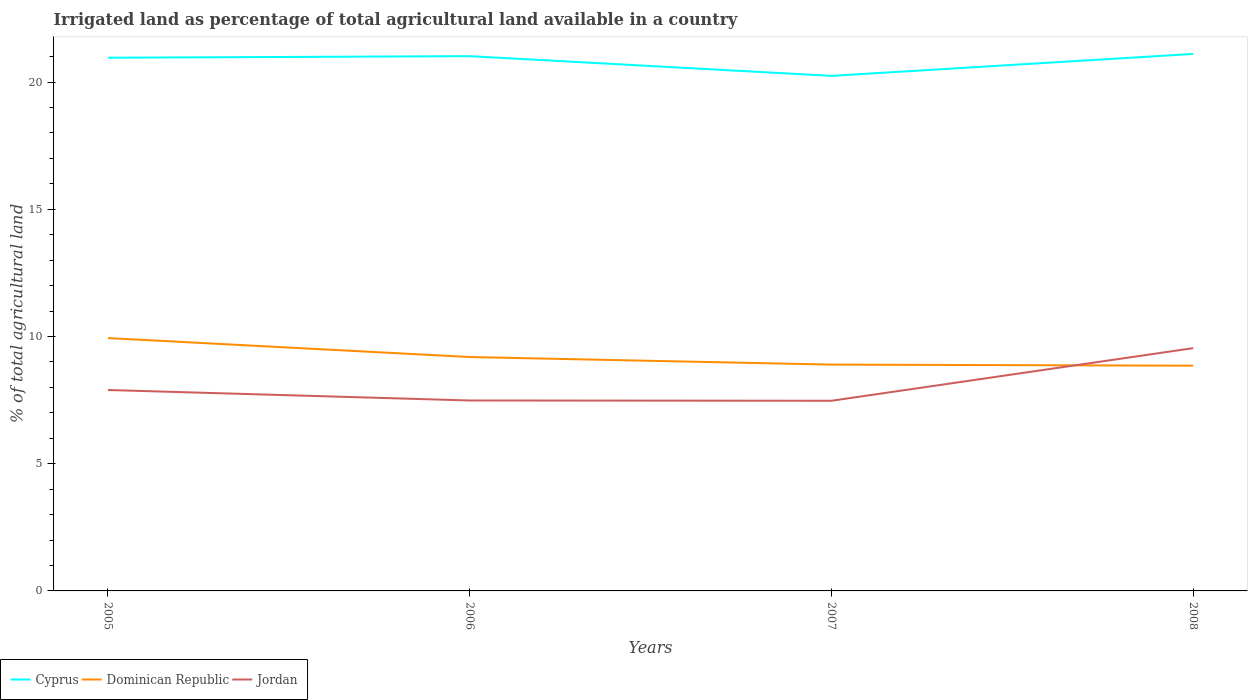Does the line corresponding to Cyprus intersect with the line corresponding to Jordan?
Give a very brief answer. No. Across all years, what is the maximum percentage of irrigated land in Cyprus?
Ensure brevity in your answer.  20.24. What is the total percentage of irrigated land in Jordan in the graph?
Offer a very short reply. 0.01. What is the difference between the highest and the second highest percentage of irrigated land in Jordan?
Offer a terse response. 2.07. What is the difference between the highest and the lowest percentage of irrigated land in Cyprus?
Give a very brief answer. 3. How many lines are there?
Keep it short and to the point. 3. How many years are there in the graph?
Your answer should be compact. 4. Does the graph contain any zero values?
Make the answer very short. No. How many legend labels are there?
Your response must be concise. 3. What is the title of the graph?
Make the answer very short. Irrigated land as percentage of total agricultural land available in a country. Does "Ghana" appear as one of the legend labels in the graph?
Provide a short and direct response. No. What is the label or title of the Y-axis?
Your answer should be compact. % of total agricultural land. What is the % of total agricultural land of Cyprus in 2005?
Provide a short and direct response. 20.96. What is the % of total agricultural land in Dominican Republic in 2005?
Your answer should be very brief. 9.94. What is the % of total agricultural land of Jordan in 2005?
Offer a very short reply. 7.9. What is the % of total agricultural land in Cyprus in 2006?
Provide a short and direct response. 21.02. What is the % of total agricultural land in Dominican Republic in 2006?
Provide a short and direct response. 9.19. What is the % of total agricultural land in Jordan in 2006?
Your response must be concise. 7.49. What is the % of total agricultural land in Cyprus in 2007?
Ensure brevity in your answer.  20.24. What is the % of total agricultural land in Dominican Republic in 2007?
Offer a terse response. 8.9. What is the % of total agricultural land in Jordan in 2007?
Keep it short and to the point. 7.47. What is the % of total agricultural land of Cyprus in 2008?
Offer a terse response. 21.11. What is the % of total agricultural land of Dominican Republic in 2008?
Give a very brief answer. 8.85. What is the % of total agricultural land of Jordan in 2008?
Give a very brief answer. 9.54. Across all years, what is the maximum % of total agricultural land of Cyprus?
Offer a very short reply. 21.11. Across all years, what is the maximum % of total agricultural land of Dominican Republic?
Keep it short and to the point. 9.94. Across all years, what is the maximum % of total agricultural land in Jordan?
Your answer should be compact. 9.54. Across all years, what is the minimum % of total agricultural land of Cyprus?
Make the answer very short. 20.24. Across all years, what is the minimum % of total agricultural land in Dominican Republic?
Provide a short and direct response. 8.85. Across all years, what is the minimum % of total agricultural land in Jordan?
Your answer should be very brief. 7.47. What is the total % of total agricultural land in Cyprus in the graph?
Offer a very short reply. 83.33. What is the total % of total agricultural land in Dominican Republic in the graph?
Make the answer very short. 36.88. What is the total % of total agricultural land of Jordan in the graph?
Offer a terse response. 32.4. What is the difference between the % of total agricultural land in Cyprus in 2005 and that in 2006?
Provide a succinct answer. -0.06. What is the difference between the % of total agricultural land in Dominican Republic in 2005 and that in 2006?
Offer a terse response. 0.74. What is the difference between the % of total agricultural land of Jordan in 2005 and that in 2006?
Provide a short and direct response. 0.41. What is the difference between the % of total agricultural land of Cyprus in 2005 and that in 2007?
Your answer should be very brief. 0.71. What is the difference between the % of total agricultural land in Dominican Republic in 2005 and that in 2007?
Provide a succinct answer. 1.04. What is the difference between the % of total agricultural land in Jordan in 2005 and that in 2007?
Your answer should be compact. 0.42. What is the difference between the % of total agricultural land in Cyprus in 2005 and that in 2008?
Your answer should be compact. -0.15. What is the difference between the % of total agricultural land of Dominican Republic in 2005 and that in 2008?
Offer a terse response. 1.09. What is the difference between the % of total agricultural land in Jordan in 2005 and that in 2008?
Offer a very short reply. -1.65. What is the difference between the % of total agricultural land in Cyprus in 2006 and that in 2007?
Your response must be concise. 0.77. What is the difference between the % of total agricultural land in Dominican Republic in 2006 and that in 2007?
Your answer should be very brief. 0.3. What is the difference between the % of total agricultural land of Jordan in 2006 and that in 2007?
Provide a succinct answer. 0.01. What is the difference between the % of total agricultural land in Cyprus in 2006 and that in 2008?
Ensure brevity in your answer.  -0.09. What is the difference between the % of total agricultural land of Dominican Republic in 2006 and that in 2008?
Provide a succinct answer. 0.34. What is the difference between the % of total agricultural land of Jordan in 2006 and that in 2008?
Your answer should be compact. -2.06. What is the difference between the % of total agricultural land of Cyprus in 2007 and that in 2008?
Your answer should be compact. -0.86. What is the difference between the % of total agricultural land in Dominican Republic in 2007 and that in 2008?
Keep it short and to the point. 0.04. What is the difference between the % of total agricultural land of Jordan in 2007 and that in 2008?
Ensure brevity in your answer.  -2.07. What is the difference between the % of total agricultural land of Cyprus in 2005 and the % of total agricultural land of Dominican Republic in 2006?
Provide a short and direct response. 11.76. What is the difference between the % of total agricultural land of Cyprus in 2005 and the % of total agricultural land of Jordan in 2006?
Provide a succinct answer. 13.47. What is the difference between the % of total agricultural land in Dominican Republic in 2005 and the % of total agricultural land in Jordan in 2006?
Your answer should be compact. 2.45. What is the difference between the % of total agricultural land in Cyprus in 2005 and the % of total agricultural land in Dominican Republic in 2007?
Keep it short and to the point. 12.06. What is the difference between the % of total agricultural land in Cyprus in 2005 and the % of total agricultural land in Jordan in 2007?
Give a very brief answer. 13.48. What is the difference between the % of total agricultural land of Dominican Republic in 2005 and the % of total agricultural land of Jordan in 2007?
Ensure brevity in your answer.  2.46. What is the difference between the % of total agricultural land of Cyprus in 2005 and the % of total agricultural land of Dominican Republic in 2008?
Offer a terse response. 12.11. What is the difference between the % of total agricultural land in Cyprus in 2005 and the % of total agricultural land in Jordan in 2008?
Offer a very short reply. 11.42. What is the difference between the % of total agricultural land in Dominican Republic in 2005 and the % of total agricultural land in Jordan in 2008?
Your answer should be very brief. 0.4. What is the difference between the % of total agricultural land of Cyprus in 2006 and the % of total agricultural land of Dominican Republic in 2007?
Your response must be concise. 12.12. What is the difference between the % of total agricultural land in Cyprus in 2006 and the % of total agricultural land in Jordan in 2007?
Provide a short and direct response. 13.54. What is the difference between the % of total agricultural land in Dominican Republic in 2006 and the % of total agricultural land in Jordan in 2007?
Ensure brevity in your answer.  1.72. What is the difference between the % of total agricultural land in Cyprus in 2006 and the % of total agricultural land in Dominican Republic in 2008?
Your answer should be compact. 12.17. What is the difference between the % of total agricultural land of Cyprus in 2006 and the % of total agricultural land of Jordan in 2008?
Your answer should be very brief. 11.48. What is the difference between the % of total agricultural land of Dominican Republic in 2006 and the % of total agricultural land of Jordan in 2008?
Your response must be concise. -0.35. What is the difference between the % of total agricultural land of Cyprus in 2007 and the % of total agricultural land of Dominican Republic in 2008?
Give a very brief answer. 11.39. What is the difference between the % of total agricultural land in Cyprus in 2007 and the % of total agricultural land in Jordan in 2008?
Your response must be concise. 10.7. What is the difference between the % of total agricultural land in Dominican Republic in 2007 and the % of total agricultural land in Jordan in 2008?
Your answer should be compact. -0.65. What is the average % of total agricultural land in Cyprus per year?
Ensure brevity in your answer.  20.83. What is the average % of total agricultural land in Dominican Republic per year?
Make the answer very short. 9.22. What is the average % of total agricultural land of Jordan per year?
Your answer should be very brief. 8.1. In the year 2005, what is the difference between the % of total agricultural land of Cyprus and % of total agricultural land of Dominican Republic?
Offer a very short reply. 11.02. In the year 2005, what is the difference between the % of total agricultural land in Cyprus and % of total agricultural land in Jordan?
Your answer should be very brief. 13.06. In the year 2005, what is the difference between the % of total agricultural land of Dominican Republic and % of total agricultural land of Jordan?
Give a very brief answer. 2.04. In the year 2006, what is the difference between the % of total agricultural land in Cyprus and % of total agricultural land in Dominican Republic?
Keep it short and to the point. 11.83. In the year 2006, what is the difference between the % of total agricultural land of Cyprus and % of total agricultural land of Jordan?
Your answer should be very brief. 13.53. In the year 2006, what is the difference between the % of total agricultural land of Dominican Republic and % of total agricultural land of Jordan?
Give a very brief answer. 1.71. In the year 2007, what is the difference between the % of total agricultural land of Cyprus and % of total agricultural land of Dominican Republic?
Ensure brevity in your answer.  11.35. In the year 2007, what is the difference between the % of total agricultural land in Cyprus and % of total agricultural land in Jordan?
Give a very brief answer. 12.77. In the year 2007, what is the difference between the % of total agricultural land of Dominican Republic and % of total agricultural land of Jordan?
Offer a terse response. 1.42. In the year 2008, what is the difference between the % of total agricultural land of Cyprus and % of total agricultural land of Dominican Republic?
Ensure brevity in your answer.  12.25. In the year 2008, what is the difference between the % of total agricultural land of Cyprus and % of total agricultural land of Jordan?
Ensure brevity in your answer.  11.56. In the year 2008, what is the difference between the % of total agricultural land of Dominican Republic and % of total agricultural land of Jordan?
Provide a succinct answer. -0.69. What is the ratio of the % of total agricultural land in Cyprus in 2005 to that in 2006?
Your response must be concise. 1. What is the ratio of the % of total agricultural land in Dominican Republic in 2005 to that in 2006?
Provide a short and direct response. 1.08. What is the ratio of the % of total agricultural land in Jordan in 2005 to that in 2006?
Offer a very short reply. 1.06. What is the ratio of the % of total agricultural land in Cyprus in 2005 to that in 2007?
Your answer should be compact. 1.04. What is the ratio of the % of total agricultural land of Dominican Republic in 2005 to that in 2007?
Ensure brevity in your answer.  1.12. What is the ratio of the % of total agricultural land in Jordan in 2005 to that in 2007?
Offer a very short reply. 1.06. What is the ratio of the % of total agricultural land in Dominican Republic in 2005 to that in 2008?
Keep it short and to the point. 1.12. What is the ratio of the % of total agricultural land in Jordan in 2005 to that in 2008?
Ensure brevity in your answer.  0.83. What is the ratio of the % of total agricultural land of Cyprus in 2006 to that in 2007?
Offer a very short reply. 1.04. What is the ratio of the % of total agricultural land in Dominican Republic in 2006 to that in 2007?
Offer a terse response. 1.03. What is the ratio of the % of total agricultural land in Cyprus in 2006 to that in 2008?
Keep it short and to the point. 1. What is the ratio of the % of total agricultural land of Dominican Republic in 2006 to that in 2008?
Provide a succinct answer. 1.04. What is the ratio of the % of total agricultural land of Jordan in 2006 to that in 2008?
Offer a terse response. 0.78. What is the ratio of the % of total agricultural land in Cyprus in 2007 to that in 2008?
Provide a short and direct response. 0.96. What is the ratio of the % of total agricultural land of Jordan in 2007 to that in 2008?
Your answer should be compact. 0.78. What is the difference between the highest and the second highest % of total agricultural land of Cyprus?
Provide a succinct answer. 0.09. What is the difference between the highest and the second highest % of total agricultural land of Dominican Republic?
Ensure brevity in your answer.  0.74. What is the difference between the highest and the second highest % of total agricultural land in Jordan?
Ensure brevity in your answer.  1.65. What is the difference between the highest and the lowest % of total agricultural land in Cyprus?
Ensure brevity in your answer.  0.86. What is the difference between the highest and the lowest % of total agricultural land in Dominican Republic?
Offer a terse response. 1.09. What is the difference between the highest and the lowest % of total agricultural land in Jordan?
Give a very brief answer. 2.07. 